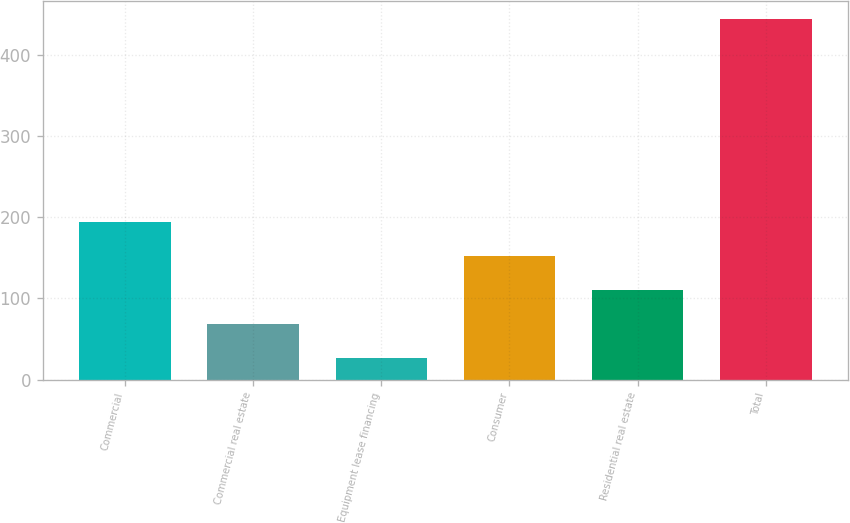Convert chart. <chart><loc_0><loc_0><loc_500><loc_500><bar_chart><fcel>Commercial<fcel>Commercial real estate<fcel>Equipment lease financing<fcel>Consumer<fcel>Residential real estate<fcel>Total<nl><fcel>193.8<fcel>68.7<fcel>27<fcel>152.1<fcel>110.4<fcel>444<nl></chart> 